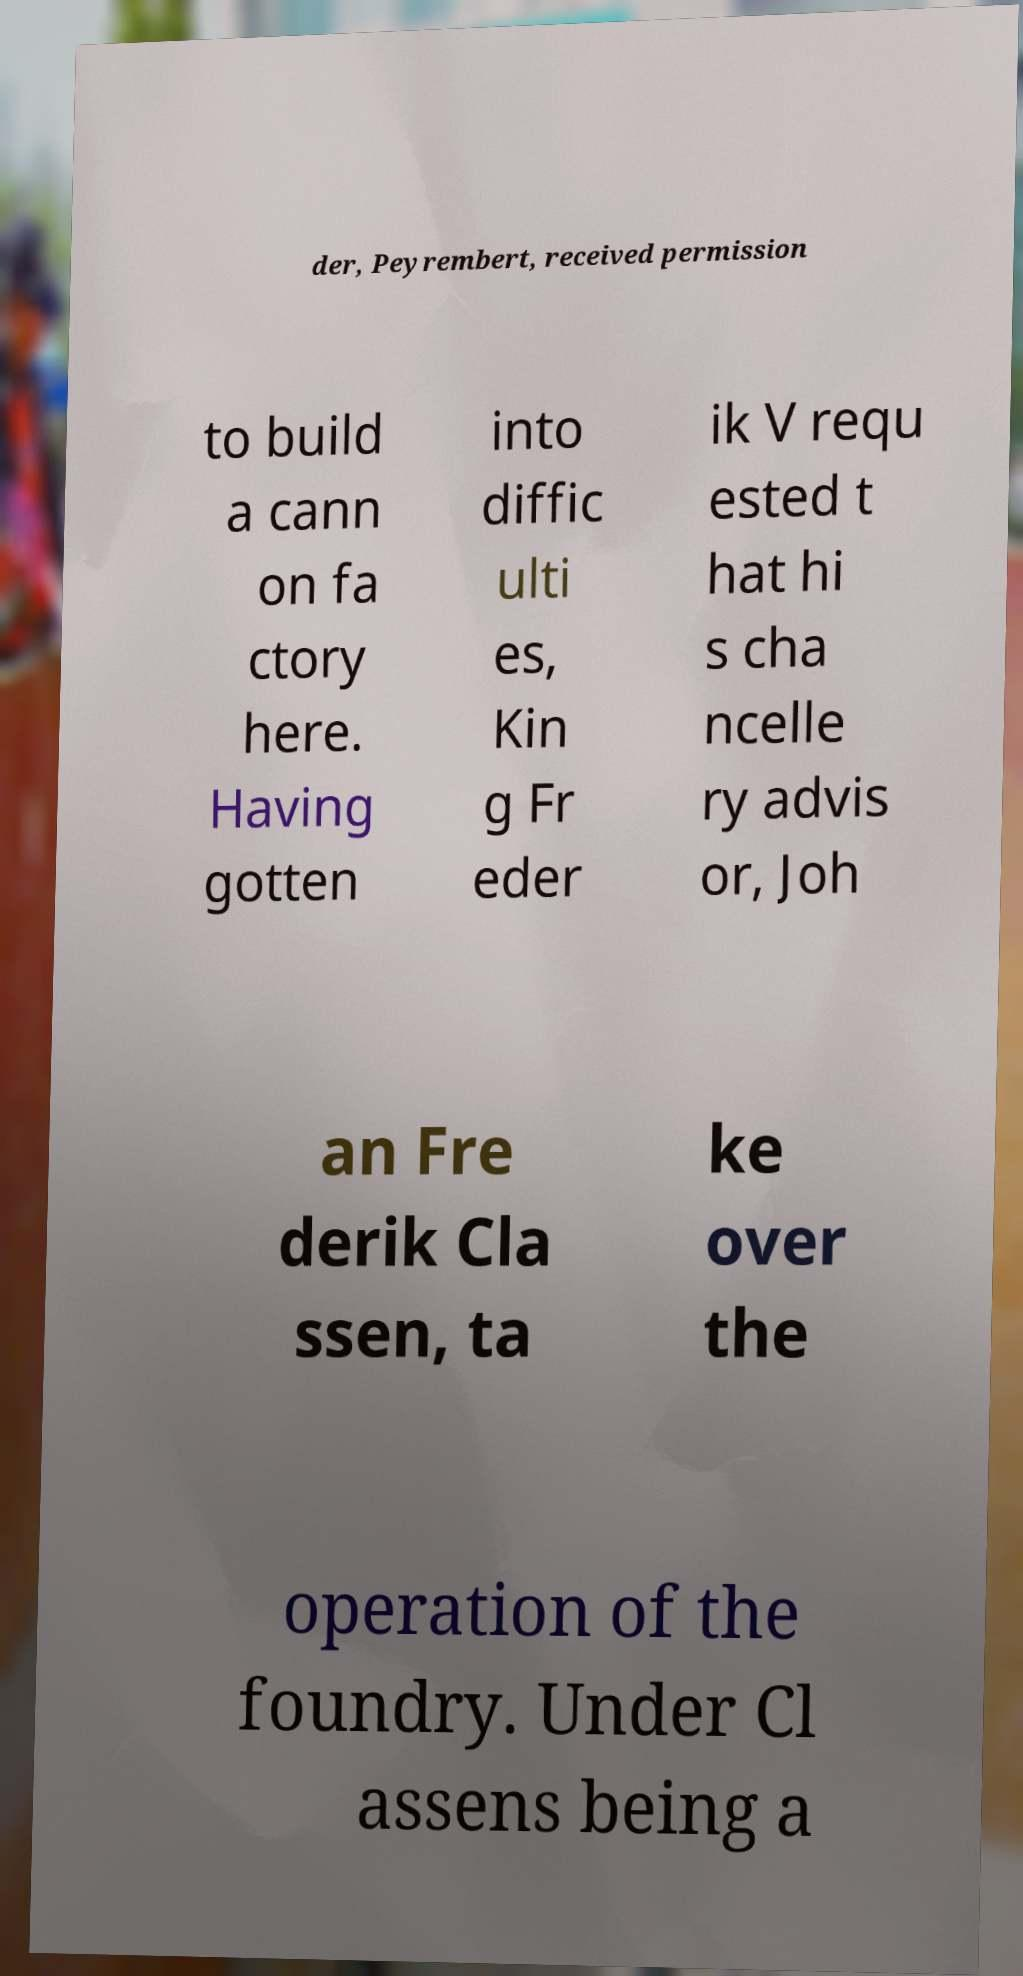Can you read and provide the text displayed in the image?This photo seems to have some interesting text. Can you extract and type it out for me? der, Peyrembert, received permission to build a cann on fa ctory here. Having gotten into diffic ulti es, Kin g Fr eder ik V requ ested t hat hi s cha ncelle ry advis or, Joh an Fre derik Cla ssen, ta ke over the operation of the foundry. Under Cl assens being a 